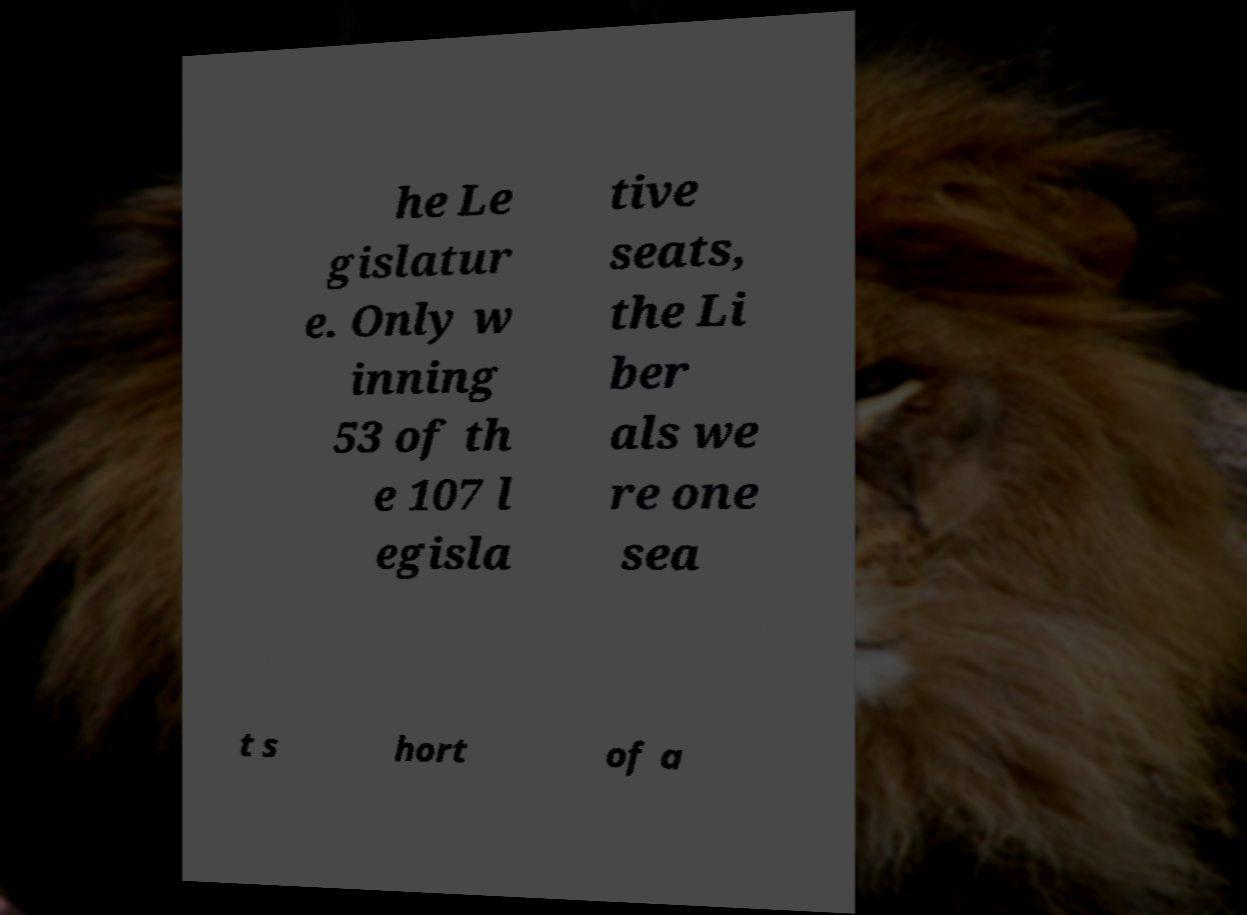Please identify and transcribe the text found in this image. he Le gislatur e. Only w inning 53 of th e 107 l egisla tive seats, the Li ber als we re one sea t s hort of a 